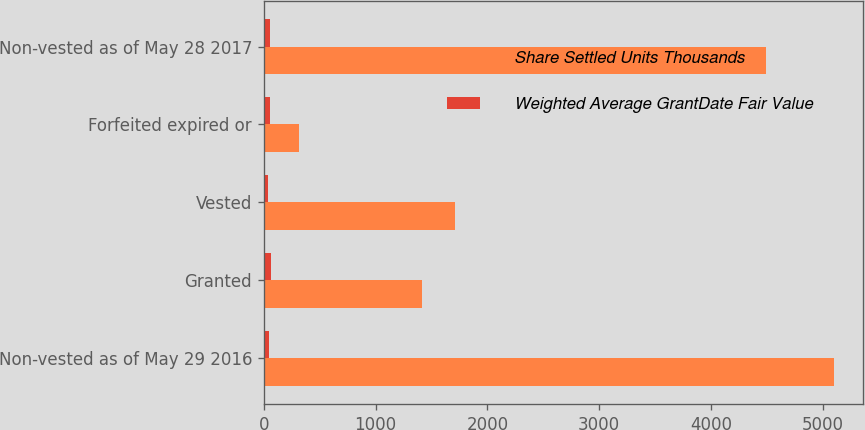<chart> <loc_0><loc_0><loc_500><loc_500><stacked_bar_chart><ecel><fcel>Non-vested as of May 29 2016<fcel>Granted<fcel>Vested<fcel>Forfeited expired or<fcel>Non-vested as of May 28 2017<nl><fcel>Share Settled Units Thousands<fcel>5100.4<fcel>1418.7<fcel>1710.3<fcel>317.6<fcel>4491.2<nl><fcel>Weighted Average GrantDate Fair Value<fcel>48.6<fcel>67.02<fcel>42.5<fcel>57.96<fcel>56.08<nl></chart> 